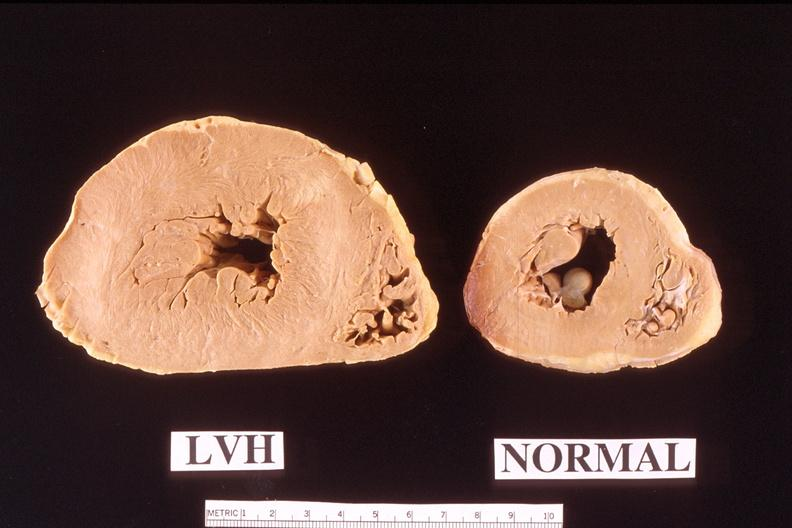does subdiaphragmatic abscess show heart?
Answer the question using a single word or phrase. No 